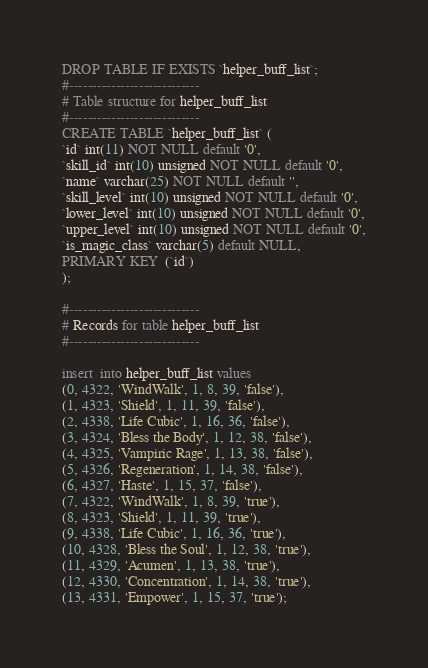<code> <loc_0><loc_0><loc_500><loc_500><_SQL_>DROP TABLE IF EXISTS `helper_buff_list`;
#----------------------------
# Table structure for helper_buff_list
#----------------------------
CREATE TABLE `helper_buff_list` (
`id` int(11) NOT NULL default '0',
`skill_id` int(10) unsigned NOT NULL default '0',
`name` varchar(25) NOT NULL default '',
`skill_level` int(10) unsigned NOT NULL default '0',
`lower_level` int(10) unsigned NOT NULL default '0',
`upper_level` int(10) unsigned NOT NULL default '0',
`is_magic_class` varchar(5) default NULL,
PRIMARY KEY  (`id`)
);

#----------------------------
# Records for table helper_buff_list
#----------------------------

insert  into helper_buff_list values 
(0, 4322, 'WindWalk', 1, 8, 39, 'false'),
(1, 4323, 'Shield', 1, 11, 39, 'false'),
(2, 4338, 'Life Cubic', 1, 16, 36, 'false'),
(3, 4324, 'Bless the Body', 1, 12, 38, 'false'),
(4, 4325, 'Vampiric Rage', 1, 13, 38, 'false'),
(5, 4326, 'Regeneration', 1, 14, 38, 'false'),
(6, 4327, 'Haste', 1, 15, 37, 'false'),
(7, 4322, 'WindWalk', 1, 8, 39, 'true'),
(8, 4323, 'Shield', 1, 11, 39, 'true'),
(9, 4338, 'Life Cubic', 1, 16, 36, 'true'),
(10, 4328, 'Bless the Soul', 1, 12, 38, 'true'),
(11, 4329, 'Acumen', 1, 13, 38, 'true'),
(12, 4330, 'Concentration', 1, 14, 38, 'true'),
(13, 4331, 'Empower', 1, 15, 37, 'true');</code> 